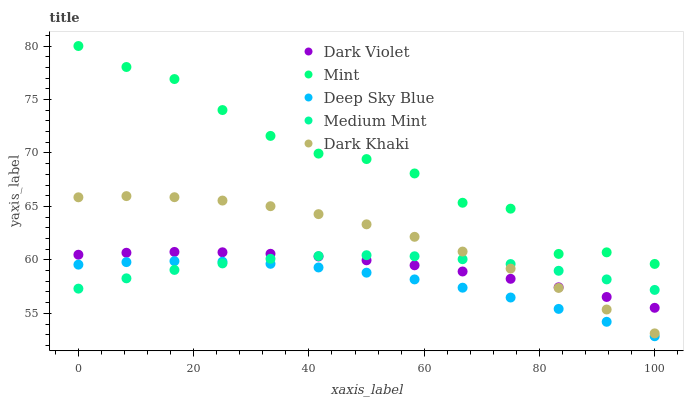Does Deep Sky Blue have the minimum area under the curve?
Answer yes or no. Yes. Does Mint have the maximum area under the curve?
Answer yes or no. Yes. Does Dark Khaki have the minimum area under the curve?
Answer yes or no. No. Does Dark Khaki have the maximum area under the curve?
Answer yes or no. No. Is Dark Violet the smoothest?
Answer yes or no. Yes. Is Mint the roughest?
Answer yes or no. Yes. Is Dark Khaki the smoothest?
Answer yes or no. No. Is Dark Khaki the roughest?
Answer yes or no. No. Does Deep Sky Blue have the lowest value?
Answer yes or no. Yes. Does Dark Khaki have the lowest value?
Answer yes or no. No. Does Mint have the highest value?
Answer yes or no. Yes. Does Dark Khaki have the highest value?
Answer yes or no. No. Is Deep Sky Blue less than Dark Violet?
Answer yes or no. Yes. Is Mint greater than Deep Sky Blue?
Answer yes or no. Yes. Does Dark Khaki intersect Dark Violet?
Answer yes or no. Yes. Is Dark Khaki less than Dark Violet?
Answer yes or no. No. Is Dark Khaki greater than Dark Violet?
Answer yes or no. No. Does Deep Sky Blue intersect Dark Violet?
Answer yes or no. No. 